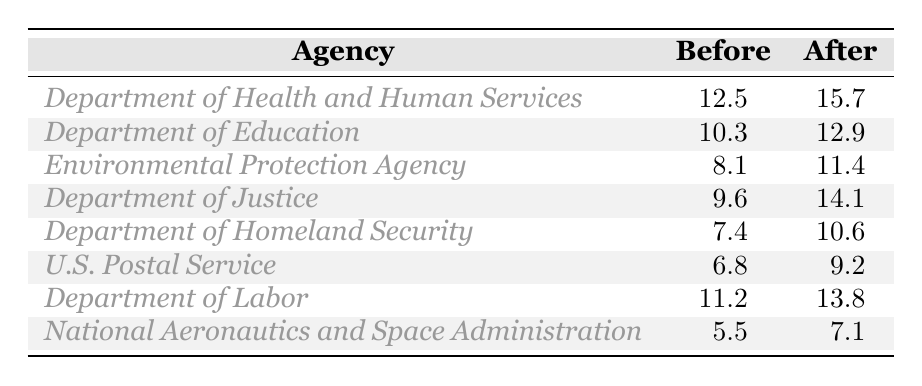What was the turnover rate for the Department of Health and Human Services before restructuring? The turnover rate for the Department of Health and Human Services before restructuring is listed in the table as 12.5.
Answer: 12.5 What is the turnover rate for the U.S. Postal Service after restructuring? The turnover rate for the U.S. Postal Service after restructuring is provided in the table, which shows it as 9.2.
Answer: 9.2 Which agency had the highest turnover rate after restructuring? By comparing the after restructuring rates in the table, the Department of Justice has the highest rate at 14.1.
Answer: Department of Justice What is the difference in turnover rates for the Department of Education before and after restructuring? The turnover rate before is 10.3 and after is 12.9. The difference is calculated as 12.9 - 10.3 = 2.6.
Answer: 2.6 What is the average turnover rate before restructuring across all agencies? To find the average, we sum the before restructuring rates (12.5 + 10.3 + 8.1 + 9.6 + 7.4 + 6.8 + 11.2 + 5.5) = 69.4. There are 8 agencies, so the average is 69.4 / 8 = 8.675.
Answer: 8.675 True or False: The turnover rate for the Department of Homeland Security decreased after restructuring. The table shows that the rate before restructuring is 7.4 and after is 10.6, indicating an increase. Therefore, the statement is false.
Answer: False Which agency experienced the smallest increase in turnover rate after restructuring? By comparing the increases, the National Aeronautics and Space Administration's increase from 5.5 to 7.1 is only 1.6, which is the smallest increase among all listed.
Answer: National Aeronautics and Space Administration What percentage increase in turnover is observed in the Environmental Protection Agency? The before rate is 8.1 and after is 11.4. The increase is (11.4 - 8.1) = 3.3. To find the percentage increase: (3.3 / 8.1) * 100 = approximately 40.74%.
Answer: 40.74% How many agencies have a turnover rate above 10 after restructuring? From the table, the agencies after restructuring that are above 10 are the Department of Health and Human Services (15.7), Department of Education (12.9), Environmental Protection Agency (11.4), and Department of Justice (14.1), totaling 4 agencies.
Answer: 4 Which agency saw the highest turnover before restructuring, and what was its rate? The highest turnover rate before restructuring is for the Department of Labor at 11.2, as indicated in the table.
Answer: Department of Labor, 11.2 